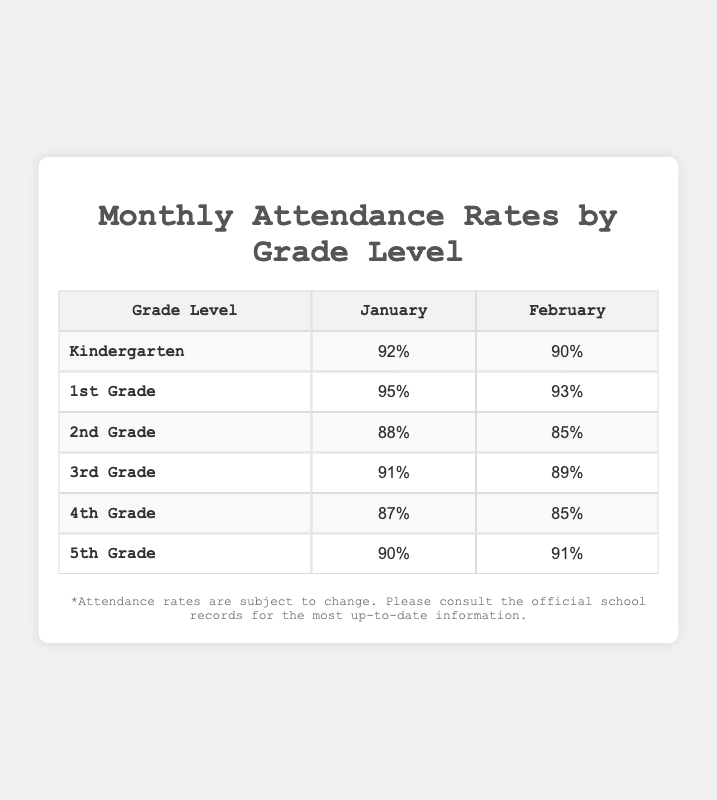What is the attendance rate for 5th Grade in January? According to the table, the 5th Grade's attendance rate in January is shown directly in the corresponding cell, which states 90%.
Answer: 90% Which month has a greater attendance rate for 1st Grade? The table shows that the attendance rate for 1st Grade in January is 95% and in February is 93%. Since 95% is greater than 93%, January has the greater attendance rate.
Answer: January What is the average attendance rate for 2nd Grade across both months? To find the average attendance rate for 2nd Grade, add both attendance rates (88% + 85% = 173%) and then divide by 2. Thus, the average is 173% / 2 = 86.5%.
Answer: 86.5% Is the attendance rate for 4th Grade higher in January than in February? The rates for 4th Grade are 87% in January and 85% in February. Since 87% is greater than 85%, the statement is true.
Answer: Yes What is the overall average attendance rate for Kindergarten and 3rd Grade in February? First, the attendance rates in February are 90% for Kindergarten and 89% for 3rd Grade. Adding these gives 90% + 89% = 179%. To find the average, divide by 2. Thus, the overall average is 179% / 2 = 89.5%.
Answer: 89.5% How does the February attendance rate for 5th Grade compare with that of 2nd Grade? The attendance rate for 5th Grade in February is 91%, while for 2nd Grade it is 85%. Since 91% is greater than 85%, 5th Grade has a higher attendance rate in February.
Answer: 5th Grade is higher What is the total attendance rate for all grades combined in January? To find the total attendance rate for January, we add the rates for each grade: 92% (Kindergarten) + 95% (1st Grade) + 88% (2nd Grade) + 91% (3rd Grade) + 87% (4th Grade) + 90% (5th Grade) = 543%. The combined total attendance rate for January is 543%.
Answer: 543% Which grade level had the lowest attendance rate in February? The attendance rates in February are 90% (Kindergarten), 93% (1st Grade), 85% (2nd Grade), 89% (3rd Grade), 85% (4th Grade), and 91% (5th Grade). Among these, the lowest attendance rates are 85% for 2nd and 4th Grade. Both share the lowest rate.
Answer: 2nd and 4th Grade 